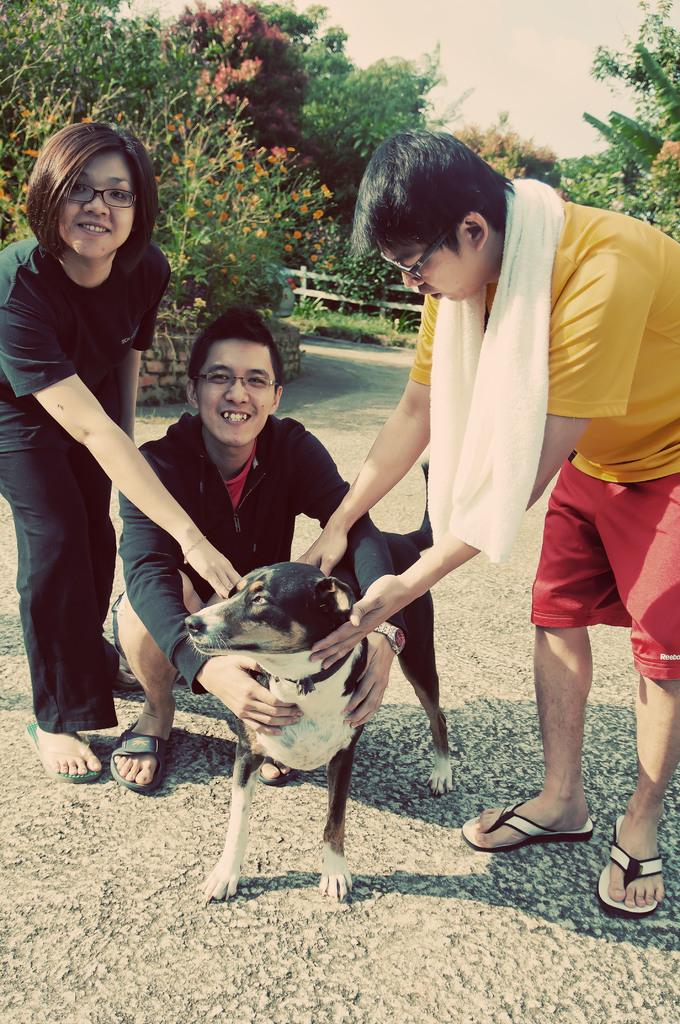How many people are in the image? There are three persons in the image. What are the persons doing in the image? The persons are holding a dog. Where is the scene taking place? The scene takes place on a road. What can be seen in the background of the image? There are many trees in the background of the image. What type of hammer can be seen in the image? There is no hammer present in the image. Can you see the sea in the background of the image? The image does not show the sea; it features a road and trees in the background. 